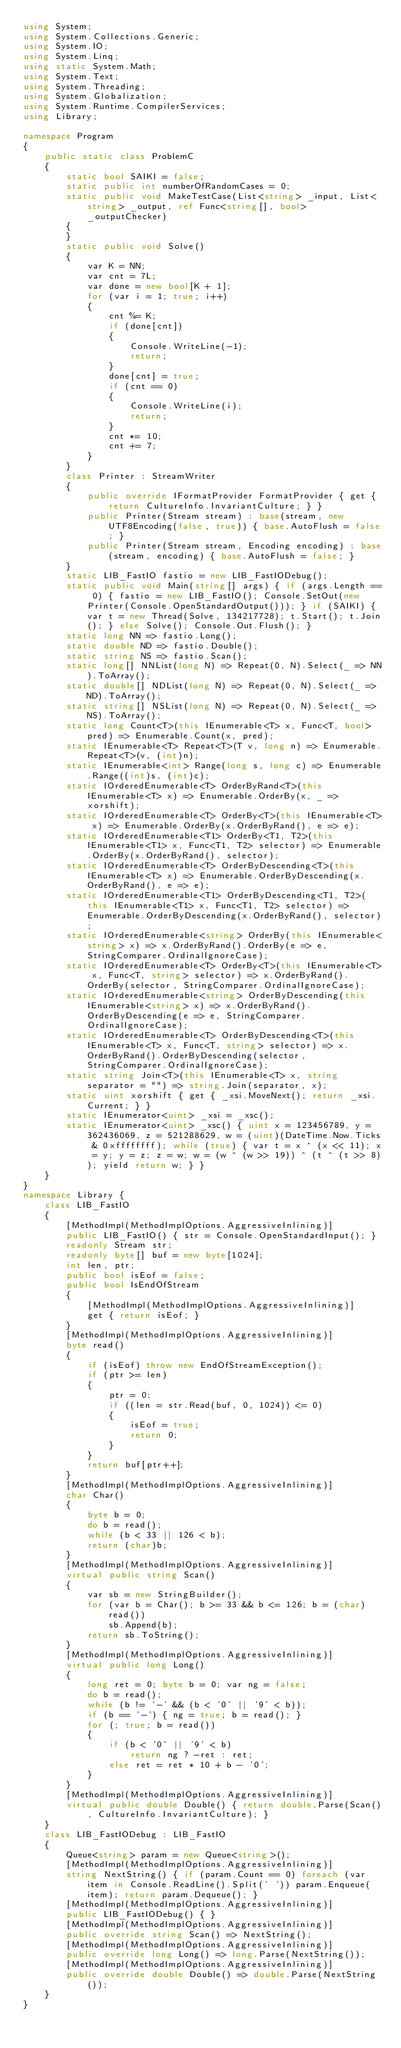<code> <loc_0><loc_0><loc_500><loc_500><_C#_>using System;
using System.Collections.Generic;
using System.IO;
using System.Linq;
using static System.Math;
using System.Text;
using System.Threading;
using System.Globalization;
using System.Runtime.CompilerServices;
using Library;

namespace Program
{
    public static class ProblemC
    {
        static bool SAIKI = false;
        static public int numberOfRandomCases = 0;
        static public void MakeTestCase(List<string> _input, List<string> _output, ref Func<string[], bool> _outputChecker)
        {
        }
        static public void Solve()
        {
            var K = NN;
            var cnt = 7L;
            var done = new bool[K + 1];
            for (var i = 1; true; i++)
            {
                cnt %= K;
                if (done[cnt])
                {
                    Console.WriteLine(-1);
                    return;
                }
                done[cnt] = true;
                if (cnt == 0)
                {
                    Console.WriteLine(i);
                    return;
                }
                cnt *= 10;
                cnt += 7;
            }
        }
        class Printer : StreamWriter
        {
            public override IFormatProvider FormatProvider { get { return CultureInfo.InvariantCulture; } }
            public Printer(Stream stream) : base(stream, new UTF8Encoding(false, true)) { base.AutoFlush = false; }
            public Printer(Stream stream, Encoding encoding) : base(stream, encoding) { base.AutoFlush = false; }
        }
        static LIB_FastIO fastio = new LIB_FastIODebug();
        static public void Main(string[] args) { if (args.Length == 0) { fastio = new LIB_FastIO(); Console.SetOut(new Printer(Console.OpenStandardOutput())); } if (SAIKI) { var t = new Thread(Solve, 134217728); t.Start(); t.Join(); } else Solve(); Console.Out.Flush(); }
        static long NN => fastio.Long();
        static double ND => fastio.Double();
        static string NS => fastio.Scan();
        static long[] NNList(long N) => Repeat(0, N).Select(_ => NN).ToArray();
        static double[] NDList(long N) => Repeat(0, N).Select(_ => ND).ToArray();
        static string[] NSList(long N) => Repeat(0, N).Select(_ => NS).ToArray();
        static long Count<T>(this IEnumerable<T> x, Func<T, bool> pred) => Enumerable.Count(x, pred);
        static IEnumerable<T> Repeat<T>(T v, long n) => Enumerable.Repeat<T>(v, (int)n);
        static IEnumerable<int> Range(long s, long c) => Enumerable.Range((int)s, (int)c);
        static IOrderedEnumerable<T> OrderByRand<T>(this IEnumerable<T> x) => Enumerable.OrderBy(x, _ => xorshift);
        static IOrderedEnumerable<T> OrderBy<T>(this IEnumerable<T> x) => Enumerable.OrderBy(x.OrderByRand(), e => e);
        static IOrderedEnumerable<T1> OrderBy<T1, T2>(this IEnumerable<T1> x, Func<T1, T2> selector) => Enumerable.OrderBy(x.OrderByRand(), selector);
        static IOrderedEnumerable<T> OrderByDescending<T>(this IEnumerable<T> x) => Enumerable.OrderByDescending(x.OrderByRand(), e => e);
        static IOrderedEnumerable<T1> OrderByDescending<T1, T2>(this IEnumerable<T1> x, Func<T1, T2> selector) => Enumerable.OrderByDescending(x.OrderByRand(), selector);
        static IOrderedEnumerable<string> OrderBy(this IEnumerable<string> x) => x.OrderByRand().OrderBy(e => e, StringComparer.OrdinalIgnoreCase);
        static IOrderedEnumerable<T> OrderBy<T>(this IEnumerable<T> x, Func<T, string> selector) => x.OrderByRand().OrderBy(selector, StringComparer.OrdinalIgnoreCase);
        static IOrderedEnumerable<string> OrderByDescending(this IEnumerable<string> x) => x.OrderByRand().OrderByDescending(e => e, StringComparer.OrdinalIgnoreCase);
        static IOrderedEnumerable<T> OrderByDescending<T>(this IEnumerable<T> x, Func<T, string> selector) => x.OrderByRand().OrderByDescending(selector, StringComparer.OrdinalIgnoreCase);
        static string Join<T>(this IEnumerable<T> x, string separator = "") => string.Join(separator, x);
        static uint xorshift { get { _xsi.MoveNext(); return _xsi.Current; } }
        static IEnumerator<uint> _xsi = _xsc();
        static IEnumerator<uint> _xsc() { uint x = 123456789, y = 362436069, z = 521288629, w = (uint)(DateTime.Now.Ticks & 0xffffffff); while (true) { var t = x ^ (x << 11); x = y; y = z; z = w; w = (w ^ (w >> 19)) ^ (t ^ (t >> 8)); yield return w; } }
    }
}
namespace Library {
    class LIB_FastIO
    {
        [MethodImpl(MethodImplOptions.AggressiveInlining)]
        public LIB_FastIO() { str = Console.OpenStandardInput(); }
        readonly Stream str;
        readonly byte[] buf = new byte[1024];
        int len, ptr;
        public bool isEof = false;
        public bool IsEndOfStream
        {
            [MethodImpl(MethodImplOptions.AggressiveInlining)]
            get { return isEof; }
        }
        [MethodImpl(MethodImplOptions.AggressiveInlining)]
        byte read()
        {
            if (isEof) throw new EndOfStreamException();
            if (ptr >= len)
            {
                ptr = 0;
                if ((len = str.Read(buf, 0, 1024)) <= 0)
                {
                    isEof = true;
                    return 0;
                }
            }
            return buf[ptr++];
        }
        [MethodImpl(MethodImplOptions.AggressiveInlining)]
        char Char()
        {
            byte b = 0;
            do b = read();
            while (b < 33 || 126 < b);
            return (char)b;
        }
        [MethodImpl(MethodImplOptions.AggressiveInlining)]
        virtual public string Scan()
        {
            var sb = new StringBuilder();
            for (var b = Char(); b >= 33 && b <= 126; b = (char)read())
                sb.Append(b);
            return sb.ToString();
        }
        [MethodImpl(MethodImplOptions.AggressiveInlining)]
        virtual public long Long()
        {
            long ret = 0; byte b = 0; var ng = false;
            do b = read();
            while (b != '-' && (b < '0' || '9' < b));
            if (b == '-') { ng = true; b = read(); }
            for (; true; b = read())
            {
                if (b < '0' || '9' < b)
                    return ng ? -ret : ret;
                else ret = ret * 10 + b - '0';
            }
        }
        [MethodImpl(MethodImplOptions.AggressiveInlining)]
        virtual public double Double() { return double.Parse(Scan(), CultureInfo.InvariantCulture); }
    }
    class LIB_FastIODebug : LIB_FastIO
    {
        Queue<string> param = new Queue<string>();
        [MethodImpl(MethodImplOptions.AggressiveInlining)]
        string NextString() { if (param.Count == 0) foreach (var item in Console.ReadLine().Split(' ')) param.Enqueue(item); return param.Dequeue(); }
        [MethodImpl(MethodImplOptions.AggressiveInlining)]
        public LIB_FastIODebug() { }
        [MethodImpl(MethodImplOptions.AggressiveInlining)]
        public override string Scan() => NextString();
        [MethodImpl(MethodImplOptions.AggressiveInlining)]
        public override long Long() => long.Parse(NextString());
        [MethodImpl(MethodImplOptions.AggressiveInlining)]
        public override double Double() => double.Parse(NextString());
    }
}
</code> 